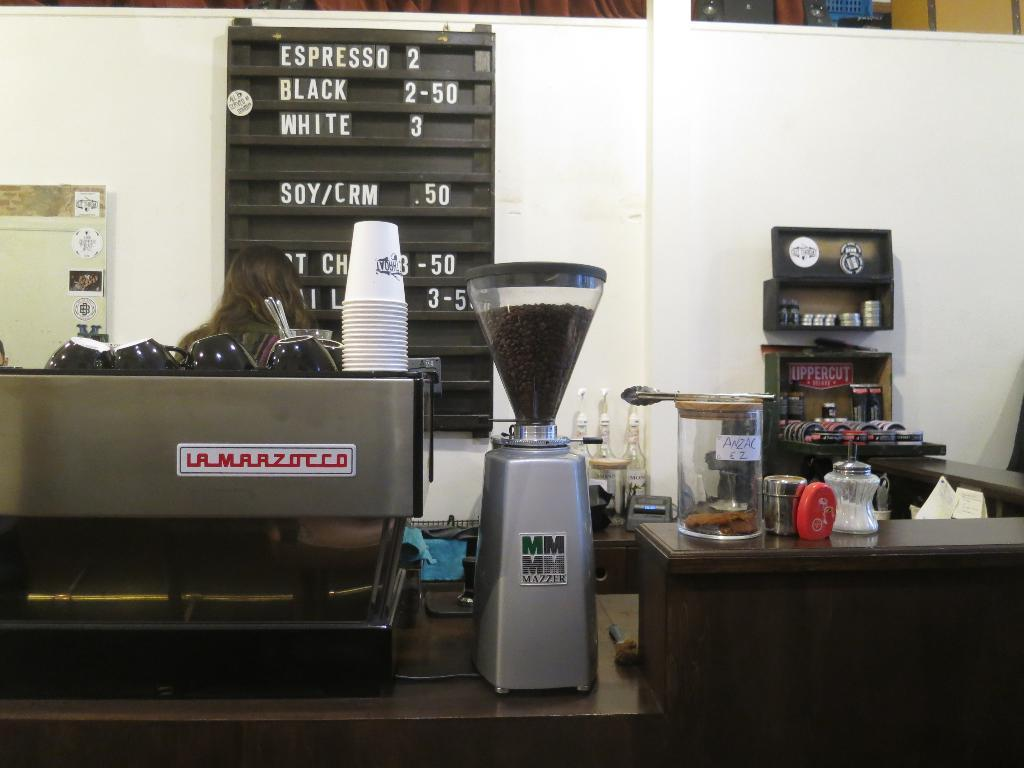<image>
Give a short and clear explanation of the subsequent image. The coffee shop sells espresso for two dollars 